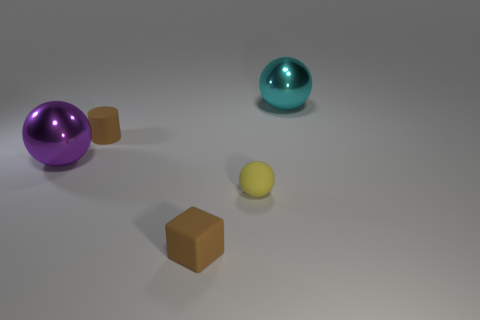Subtract all matte spheres. How many spheres are left? 2 Subtract all purple balls. How many balls are left? 2 Add 2 small cyan matte spheres. How many objects exist? 7 Subtract all yellow cubes. How many yellow cylinders are left? 0 Add 4 big red metal cubes. How many big red metal cubes exist? 4 Subtract 0 purple cubes. How many objects are left? 5 Subtract all cubes. How many objects are left? 4 Subtract 1 blocks. How many blocks are left? 0 Subtract all brown balls. Subtract all green blocks. How many balls are left? 3 Subtract all cyan things. Subtract all spheres. How many objects are left? 1 